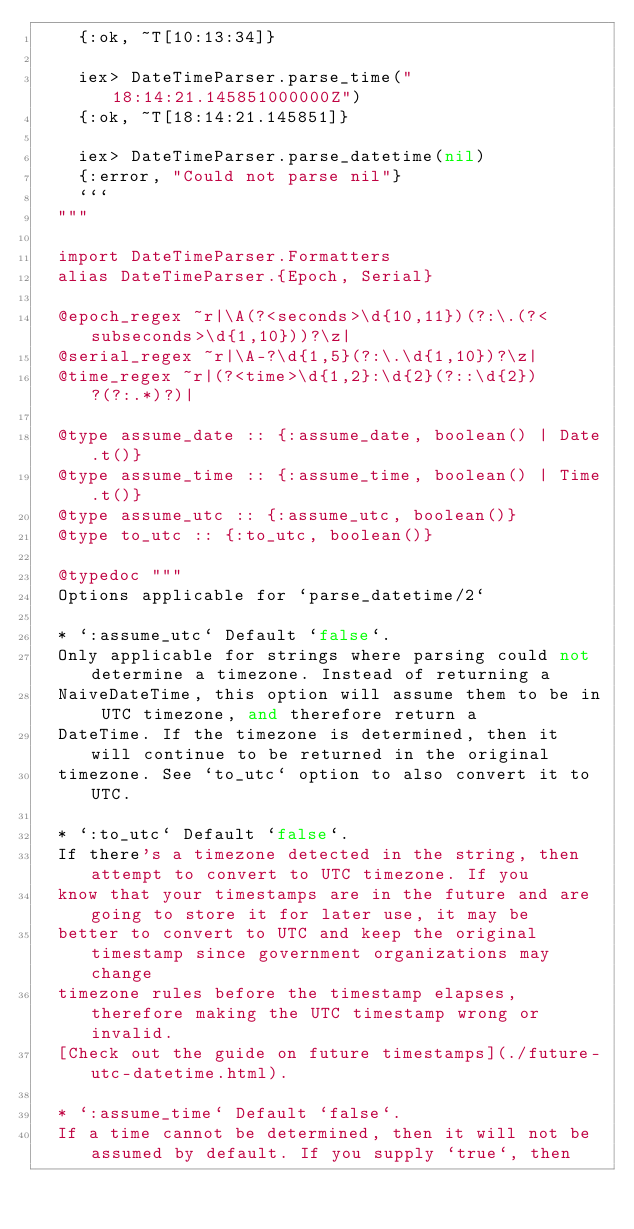<code> <loc_0><loc_0><loc_500><loc_500><_Elixir_>    {:ok, ~T[10:13:34]}

    iex> DateTimeParser.parse_time("18:14:21.145851000000Z")
    {:ok, ~T[18:14:21.145851]}

    iex> DateTimeParser.parse_datetime(nil)
    {:error, "Could not parse nil"}
    ```
  """

  import DateTimeParser.Formatters
  alias DateTimeParser.{Epoch, Serial}

  @epoch_regex ~r|\A(?<seconds>\d{10,11})(?:\.(?<subseconds>\d{1,10}))?\z|
  @serial_regex ~r|\A-?\d{1,5}(?:\.\d{1,10})?\z|
  @time_regex ~r|(?<time>\d{1,2}:\d{2}(?::\d{2})?(?:.*)?)|

  @type assume_date :: {:assume_date, boolean() | Date.t()}
  @type assume_time :: {:assume_time, boolean() | Time.t()}
  @type assume_utc :: {:assume_utc, boolean()}
  @type to_utc :: {:to_utc, boolean()}

  @typedoc """
  Options applicable for `parse_datetime/2`

  * `:assume_utc` Default `false`.
  Only applicable for strings where parsing could not determine a timezone. Instead of returning a
  NaiveDateTime, this option will assume them to be in UTC timezone, and therefore return a
  DateTime. If the timezone is determined, then it will continue to be returned in the original
  timezone. See `to_utc` option to also convert it to UTC.

  * `:to_utc` Default `false`.
  If there's a timezone detected in the string, then attempt to convert to UTC timezone. If you
  know that your timestamps are in the future and are going to store it for later use, it may be
  better to convert to UTC and keep the original timestamp since government organizations may change
  timezone rules before the timestamp elapses, therefore making the UTC timestamp wrong or invalid.
  [Check out the guide on future timestamps](./future-utc-datetime.html).

  * `:assume_time` Default `false`.
  If a time cannot be determined, then it will not be assumed by default. If you supply `true`, then</code> 